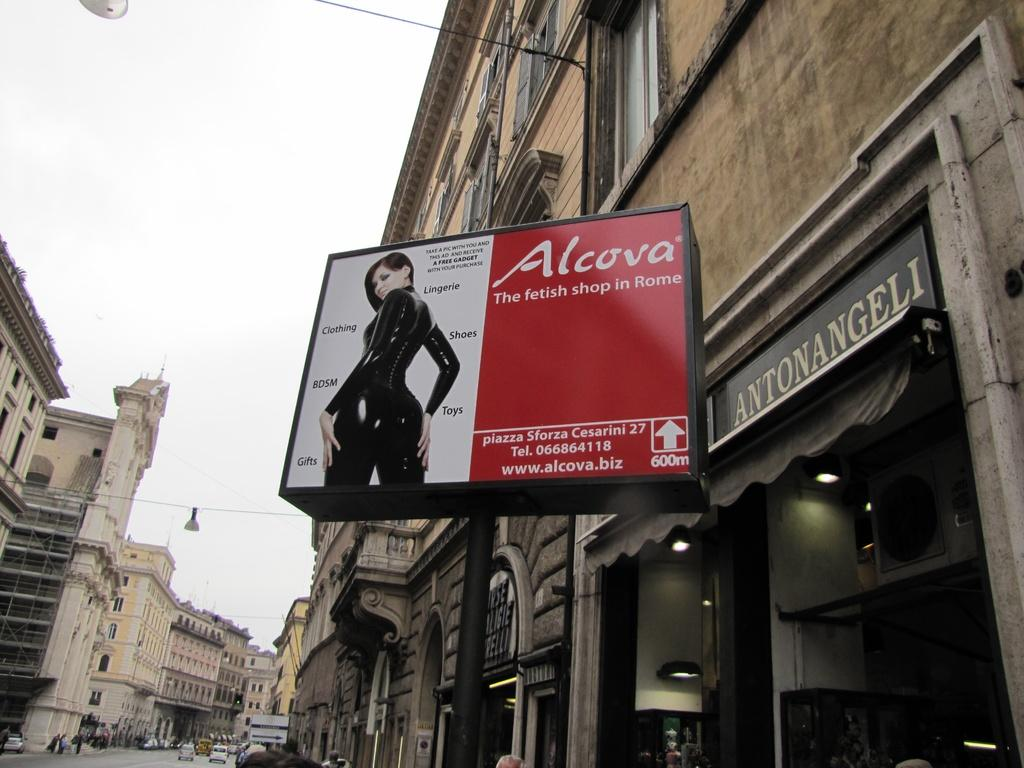<image>
Provide a brief description of the given image. A sign for Alcova fetish shop with a picture of a woman in leather on it. 